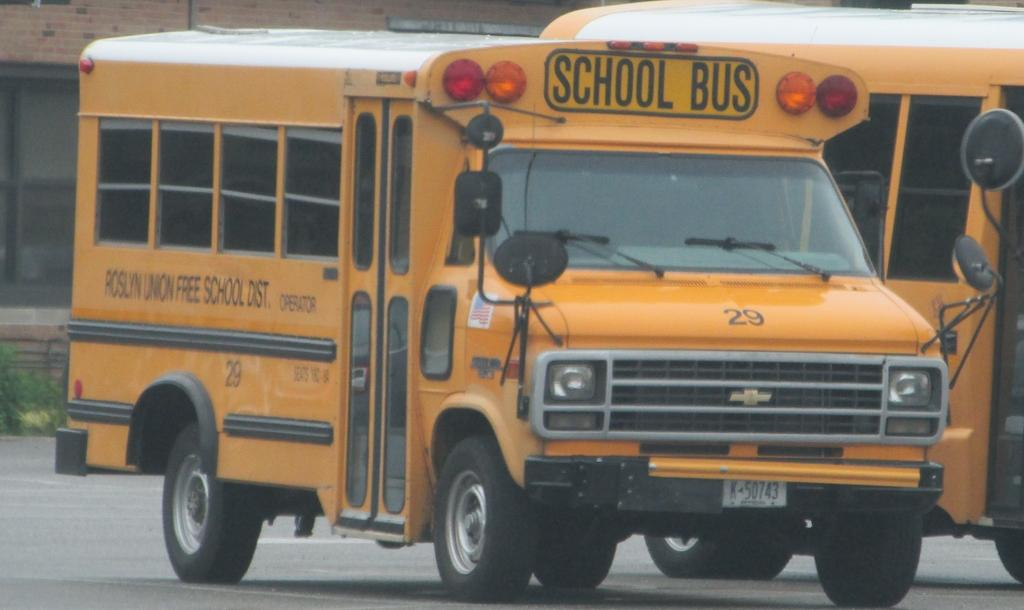<image>
Provide a brief description of the given image. A shorter school bus drives down the road. 